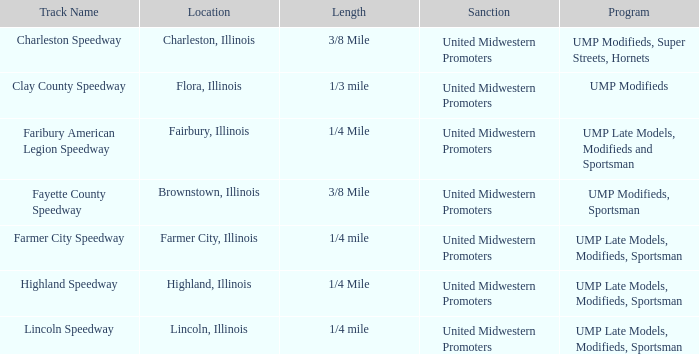What location is farmer city speedway? Farmer City, Illinois. Could you parse the entire table as a dict? {'header': ['Track Name', 'Location', 'Length', 'Sanction', 'Program'], 'rows': [['Charleston Speedway', 'Charleston, Illinois', '3/8 Mile', 'United Midwestern Promoters', 'UMP Modifieds, Super Streets, Hornets'], ['Clay County Speedway', 'Flora, Illinois', '1/3 mile', 'United Midwestern Promoters', 'UMP Modifieds'], ['Faribury American Legion Speedway', 'Fairbury, Illinois', '1/4 Mile', 'United Midwestern Promoters', 'UMP Late Models, Modifieds and Sportsman'], ['Fayette County Speedway', 'Brownstown, Illinois', '3/8 Mile', 'United Midwestern Promoters', 'UMP Modifieds, Sportsman'], ['Farmer City Speedway', 'Farmer City, Illinois', '1/4 mile', 'United Midwestern Promoters', 'UMP Late Models, Modifieds, Sportsman'], ['Highland Speedway', 'Highland, Illinois', '1/4 Mile', 'United Midwestern Promoters', 'UMP Late Models, Modifieds, Sportsman'], ['Lincoln Speedway', 'Lincoln, Illinois', '1/4 mile', 'United Midwestern Promoters', 'UMP Late Models, Modifieds, Sportsman']]} 